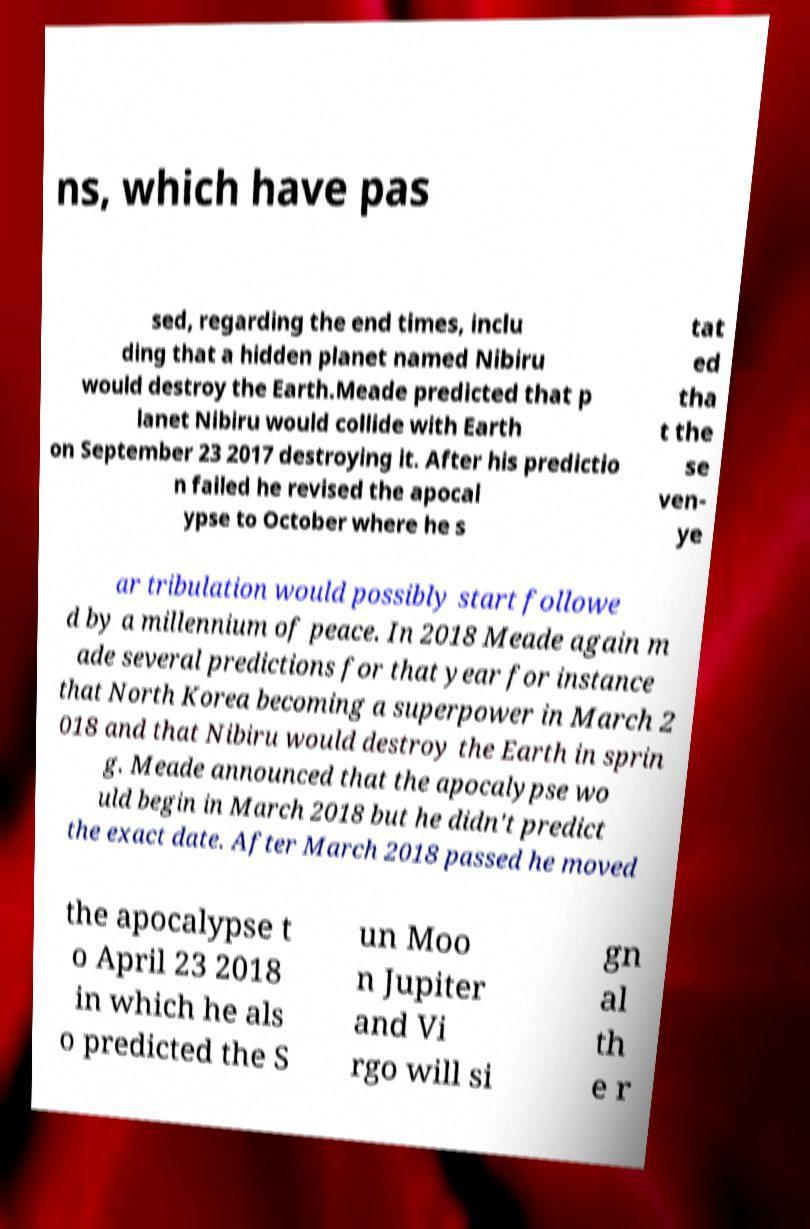Can you read and provide the text displayed in the image?This photo seems to have some interesting text. Can you extract and type it out for me? ns, which have pas sed, regarding the end times, inclu ding that a hidden planet named Nibiru would destroy the Earth.Meade predicted that p lanet Nibiru would collide with Earth on September 23 2017 destroying it. After his predictio n failed he revised the apocal ypse to October where he s tat ed tha t the se ven- ye ar tribulation would possibly start followe d by a millennium of peace. In 2018 Meade again m ade several predictions for that year for instance that North Korea becoming a superpower in March 2 018 and that Nibiru would destroy the Earth in sprin g. Meade announced that the apocalypse wo uld begin in March 2018 but he didn't predict the exact date. After March 2018 passed he moved the apocalypse t o April 23 2018 in which he als o predicted the S un Moo n Jupiter and Vi rgo will si gn al th e r 